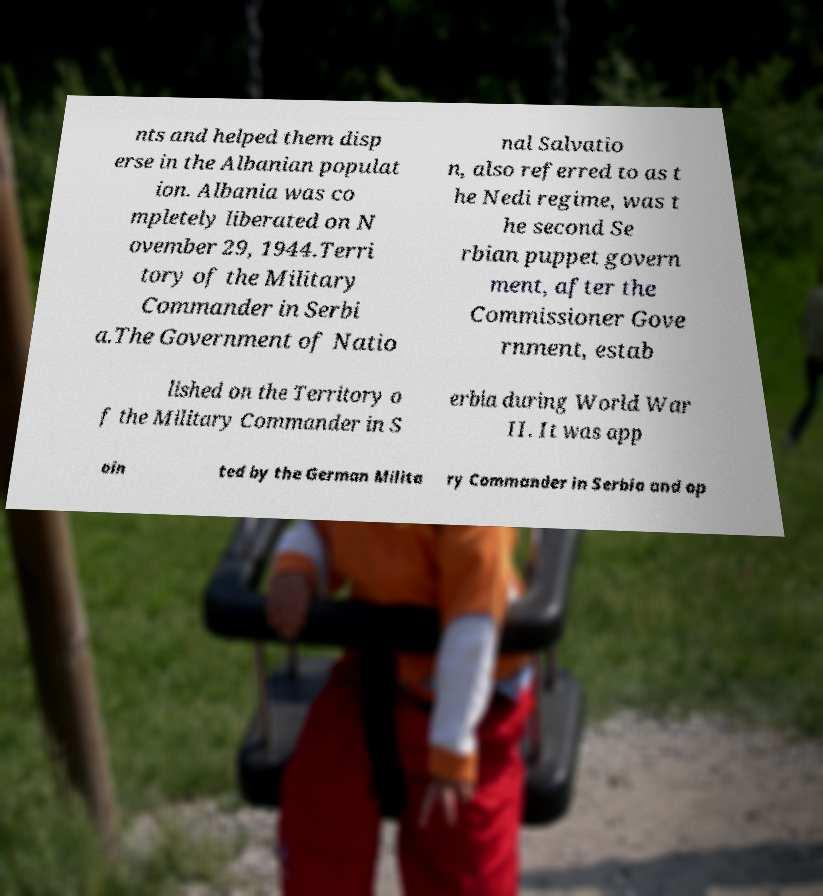There's text embedded in this image that I need extracted. Can you transcribe it verbatim? nts and helped them disp erse in the Albanian populat ion. Albania was co mpletely liberated on N ovember 29, 1944.Terri tory of the Military Commander in Serbi a.The Government of Natio nal Salvatio n, also referred to as t he Nedi regime, was t he second Se rbian puppet govern ment, after the Commissioner Gove rnment, estab lished on the Territory o f the Military Commander in S erbia during World War II. It was app oin ted by the German Milita ry Commander in Serbia and op 